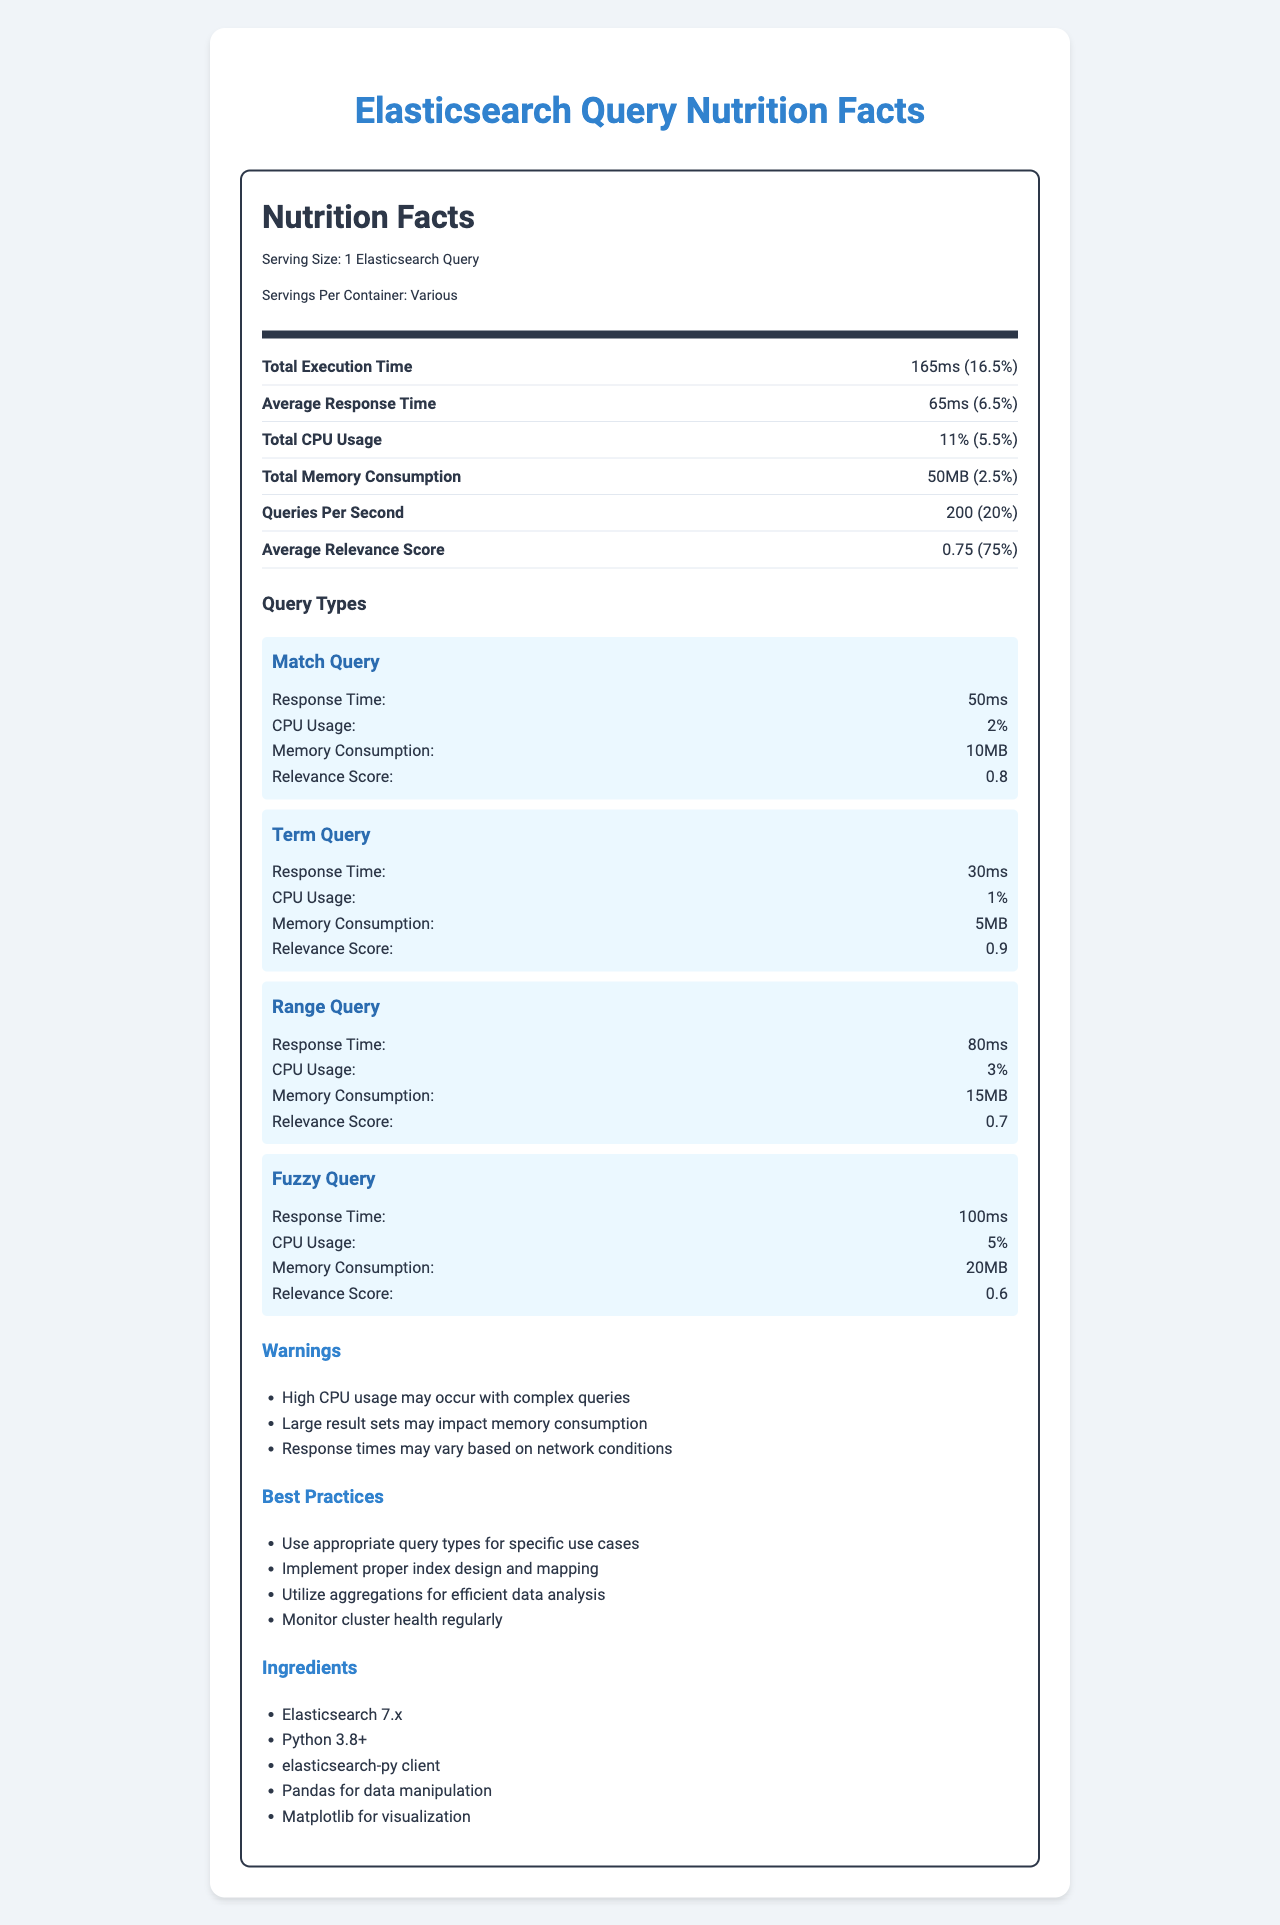what is the serving size of the Elasticsearch queries? The serving size is mentioned at the top of the document as "Serving Size: 1 Elasticsearch Query".
Answer: 1 Elasticsearch Query what is the response time of a Range Query? Under the "Query Types" section, the Range Query's response time is listed as 80ms.
Answer: 80ms how much total memory consumption is reported? In the "Resource Utilization" section, the total memory consumption is listed as 50MB.
Answer: 50MB which query type uses the most CPU? The "Query Types" section shows that the Fuzzy Query has the highest CPU usage at 5%.
Answer: Fuzzy Query what are some best practices mentioned? The best practices are listed under the "Best Practices" section.
Answer: Use appropriate query types for specific use cases, Implement proper index design and mapping, Utilize aggregations for efficient data analysis, Monitor cluster health regularly which query type has the highest relevance score? A. Term Query B. Match Query C. Fuzzy Query In the "Query Types" section, the Term Query has the highest relevance score of 0.9.
Answer: A. Term Query how many documents are in the index? A. 500,000 B. 1,000,000 C. 10,000,000 The "Index Statistics" section lists the total documents as 1,000,000.
Answer: B. 1,000,000 is caching enabled? The "Optimizations" section states that caching is enabled.
Answer: Yes summarize the main idea of the document. The document imitates a nutrition label to present various performance metrics and resource utilization details for different Elasticsearch query types executed via Python.
Answer: The document provides a detailed breakdown of Elasticsearch query performance metrics, resource utilization, and best practices. It includes specific information on query types such as Match, Term, Range, and Fuzzy Queries, as well as overall metrics like total execution time, average response time, and system resource usage. Additionally, it includes warnings, best practices, and ingredients required for implementation. what is the specific version of the elasticsearch-py client mentioned? The document does not include information about the specific version of the elasticsearch-py client used, only that it is Python-based.
Answer: Cannot be determined what percentage of the daily value does the total CPU usage represent? In the "Resource Utilization" section, the total CPU usage is listed as 11%, which is 5.5% of the daily value.
Answer: 5.5% which query type has the longest response time? The "Query Types" section lists the response time for the Fuzzy Query as 100ms, which is the longest response time.
Answer: Fuzzy Query 